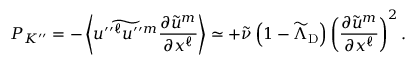<formula> <loc_0><loc_0><loc_500><loc_500>{ P } _ { K ^ { \prime \prime } } = - \left \langle { \widetilde { u ^ { \prime \prime ^ { \ell } u ^ { \prime \prime ^ { m } } \frac { \partial \widetilde { u } ^ { m } } { \partial x ^ { \ell } } } \right \rangle \simeq + \widetilde { \nu } \left ( { 1 - \widetilde { \Lambda } _ { D } } \right ) \left ( { \frac { \partial \widetilde { u } ^ { m } } { \partial x ^ { \ell } } } \right ) ^ { 2 } .</formula> 